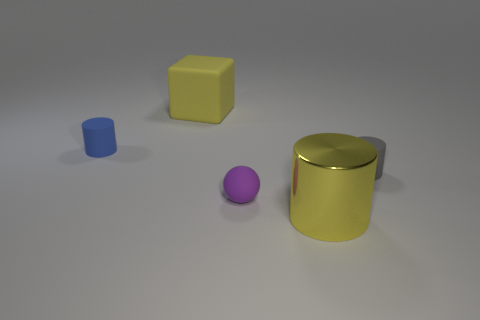Add 3 big yellow blocks. How many objects exist? 8 Subtract all balls. How many objects are left? 4 Subtract 0 brown cylinders. How many objects are left? 5 Subtract all small gray cylinders. Subtract all yellow cylinders. How many objects are left? 3 Add 4 small cylinders. How many small cylinders are left? 6 Add 5 gray matte spheres. How many gray matte spheres exist? 5 